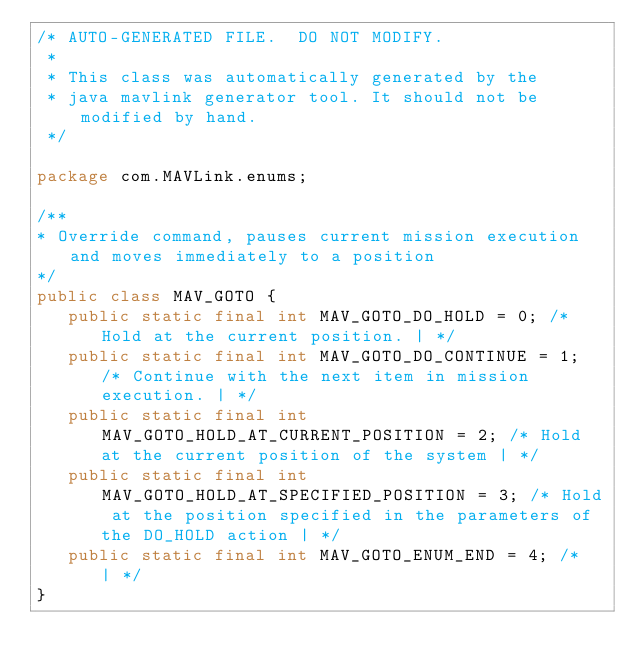<code> <loc_0><loc_0><loc_500><loc_500><_Java_>/* AUTO-GENERATED FILE.  DO NOT MODIFY.
 *
 * This class was automatically generated by the
 * java mavlink generator tool. It should not be modified by hand.
 */

package com.MAVLink.enums;

/** 
* Override command, pauses current mission execution and moves immediately to a position
*/
public class MAV_GOTO {
   public static final int MAV_GOTO_DO_HOLD = 0; /* Hold at the current position. | */
   public static final int MAV_GOTO_DO_CONTINUE = 1; /* Continue with the next item in mission execution. | */
   public static final int MAV_GOTO_HOLD_AT_CURRENT_POSITION = 2; /* Hold at the current position of the system | */
   public static final int MAV_GOTO_HOLD_AT_SPECIFIED_POSITION = 3; /* Hold at the position specified in the parameters of the DO_HOLD action | */
   public static final int MAV_GOTO_ENUM_END = 4; /*  | */
}
            </code> 